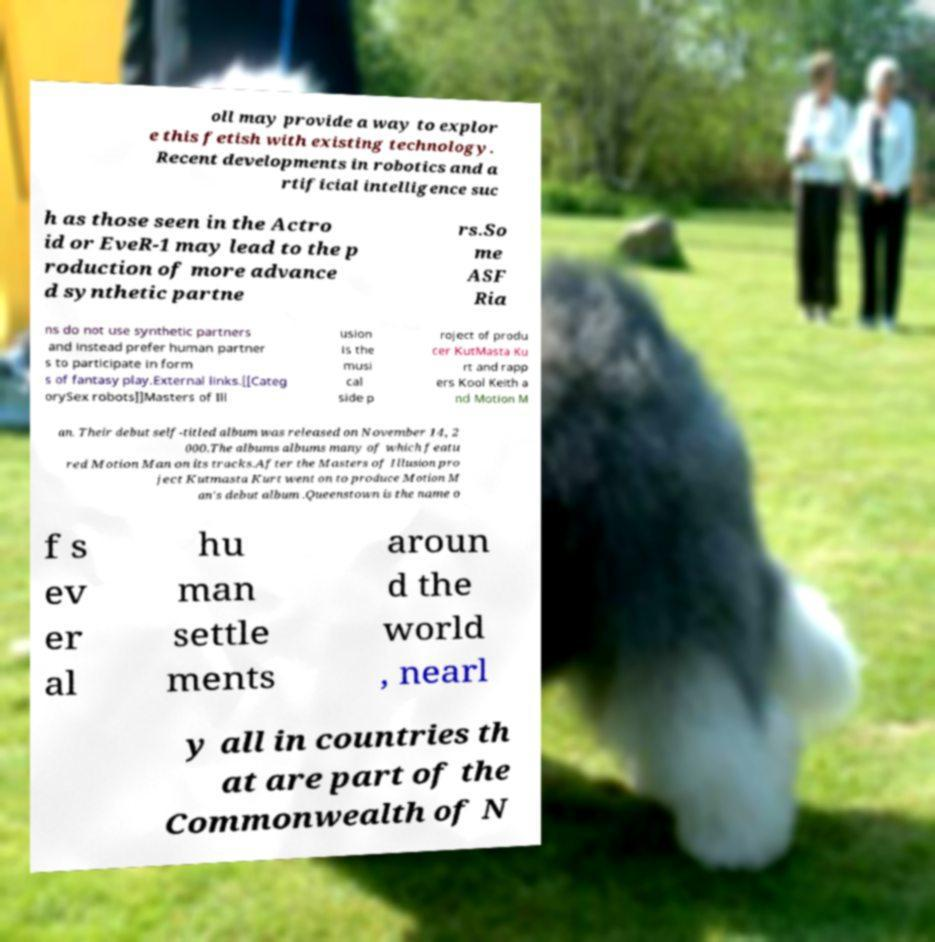What messages or text are displayed in this image? I need them in a readable, typed format. oll may provide a way to explor e this fetish with existing technology. Recent developments in robotics and a rtificial intelligence suc h as those seen in the Actro id or EveR-1 may lead to the p roduction of more advance d synthetic partne rs.So me ASF Ria ns do not use synthetic partners and instead prefer human partner s to participate in form s of fantasy play.External links.[[Categ orySex robots]]Masters of Ill usion is the musi cal side p roject of produ cer KutMasta Ku rt and rapp ers Kool Keith a nd Motion M an. Their debut self-titled album was released on November 14, 2 000.The albums albums many of which featu red Motion Man on its tracks.After the Masters of Illusion pro ject Kutmasta Kurt went on to produce Motion M an's debut album .Queenstown is the name o f s ev er al hu man settle ments aroun d the world , nearl y all in countries th at are part of the Commonwealth of N 